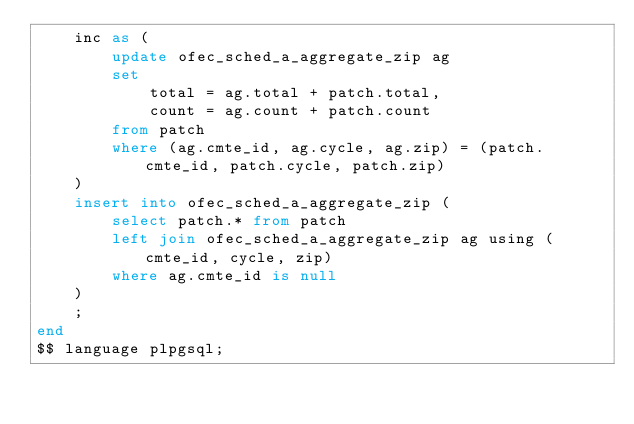Convert code to text. <code><loc_0><loc_0><loc_500><loc_500><_SQL_>    inc as (
        update ofec_sched_a_aggregate_zip ag
        set
            total = ag.total + patch.total,
            count = ag.count + patch.count
        from patch
        where (ag.cmte_id, ag.cycle, ag.zip) = (patch.cmte_id, patch.cycle, patch.zip)
    )
    insert into ofec_sched_a_aggregate_zip (
        select patch.* from patch
        left join ofec_sched_a_aggregate_zip ag using (cmte_id, cycle, zip)
        where ag.cmte_id is null
    )
    ;
end
$$ language plpgsql;
</code> 